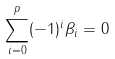<formula> <loc_0><loc_0><loc_500><loc_500>\sum _ { i = 0 } ^ { p } ( - 1 ) ^ { i } \beta _ { i } = 0</formula> 